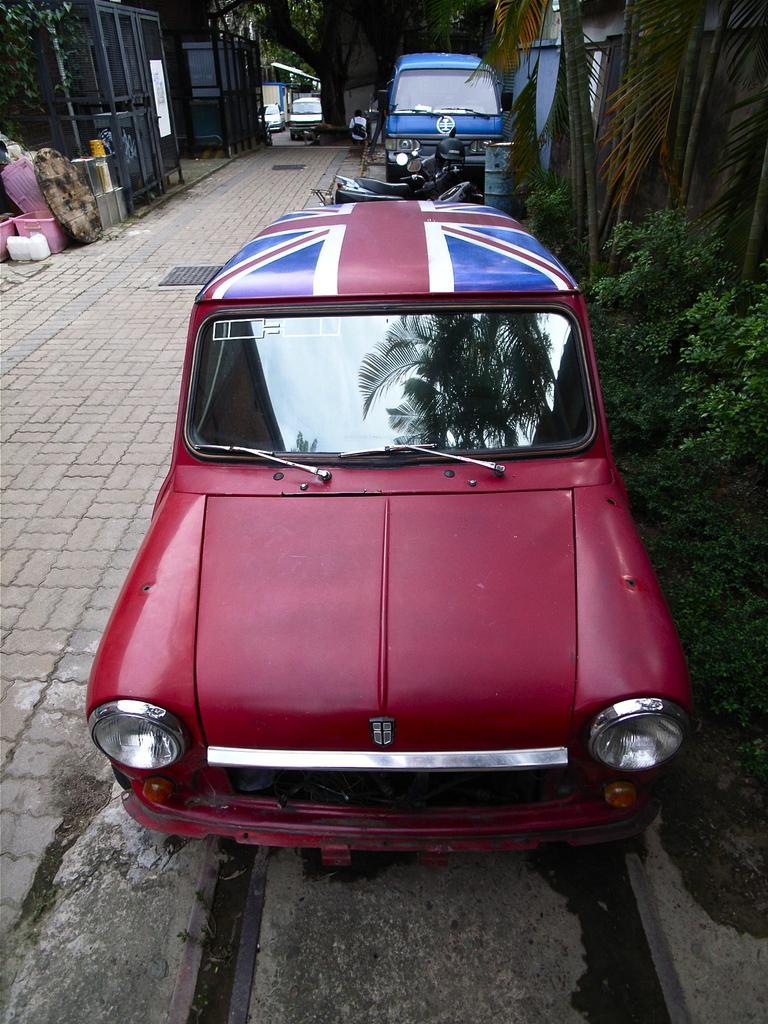Can you describe this image briefly? There is a road. On that there are drainage grills. On the sides of the road there are cars and motorcycle. On the right side there are trees. In the background there are vehicles. Also some items are kept on the side of the road. 